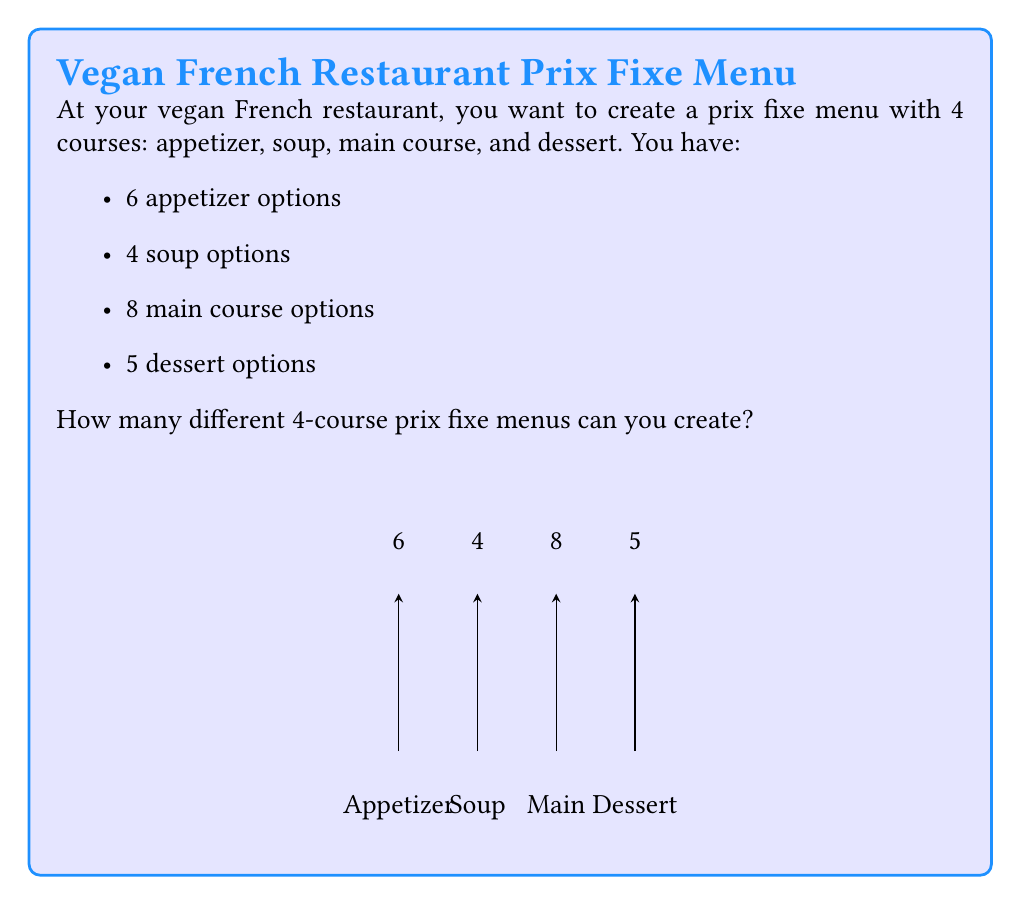Provide a solution to this math problem. Let's approach this step-by-step using the multiplication principle of counting:

1) For each course, we need to select one option from the available choices.

2) The number of ways to select each course is independent of the other courses.

3) For the appetizer, we have 6 choices.

4) For the soup, we have 4 choices.

5) For the main course, we have 8 choices.

6) For the dessert, we have 5 choices.

7) By the multiplication principle, the total number of ways to create a 4-course menu is the product of the number of choices for each course:

   $$ 6 \times 4 \times 8 \times 5 $$

8) Let's calculate this:
   $$ 6 \times 4 = 24 $$
   $$ 24 \times 8 = 192 $$
   $$ 192 \times 5 = 960 $$

Therefore, the total number of different 4-course prix fixe menus that can be created is 960.
Answer: 960 